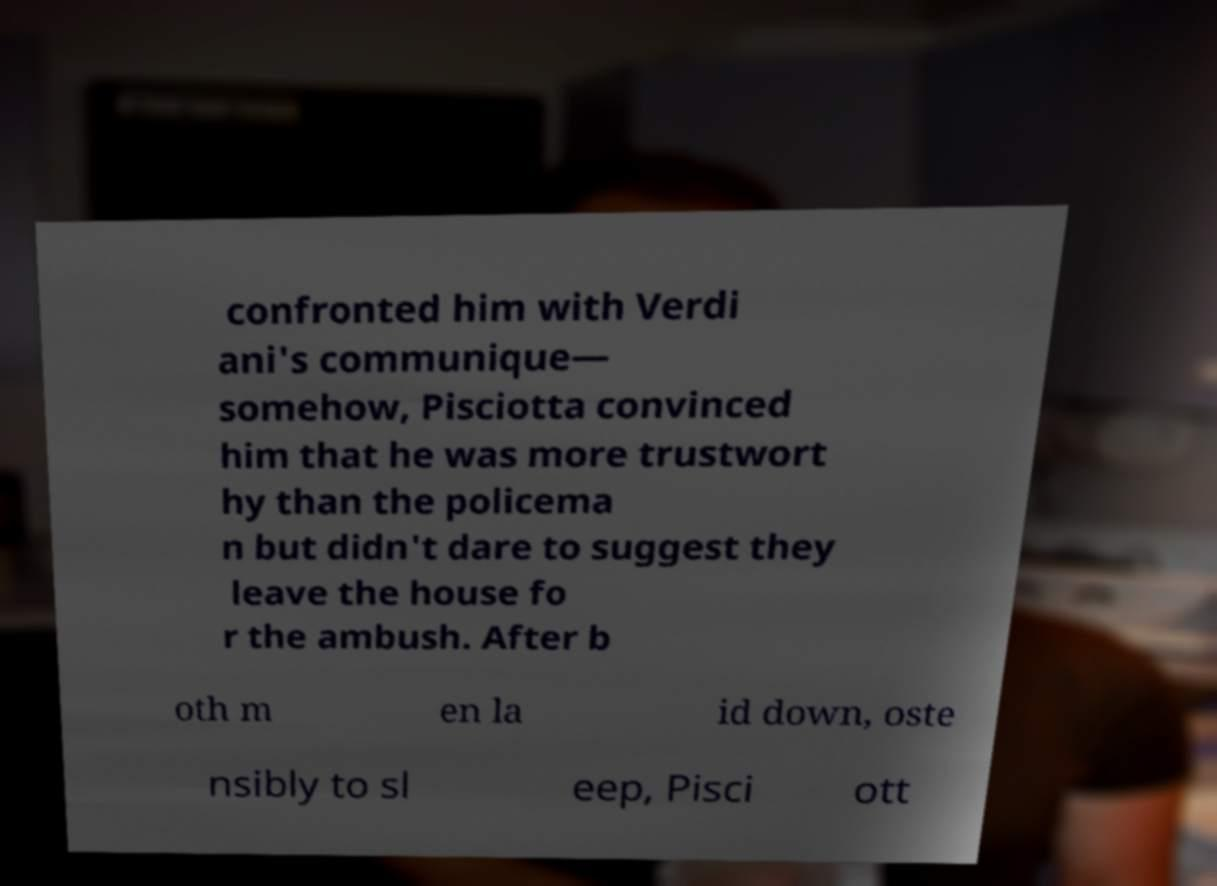What messages or text are displayed in this image? I need them in a readable, typed format. confronted him with Verdi ani's communique— somehow, Pisciotta convinced him that he was more trustwort hy than the policema n but didn't dare to suggest they leave the house fo r the ambush. After b oth m en la id down, oste nsibly to sl eep, Pisci ott 